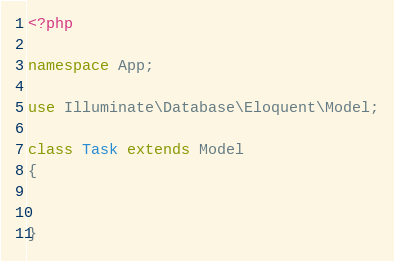Convert code to text. <code><loc_0><loc_0><loc_500><loc_500><_PHP_><?php

namespace App;

use Illuminate\Database\Eloquent\Model;

class Task extends Model
{
  

}
</code> 